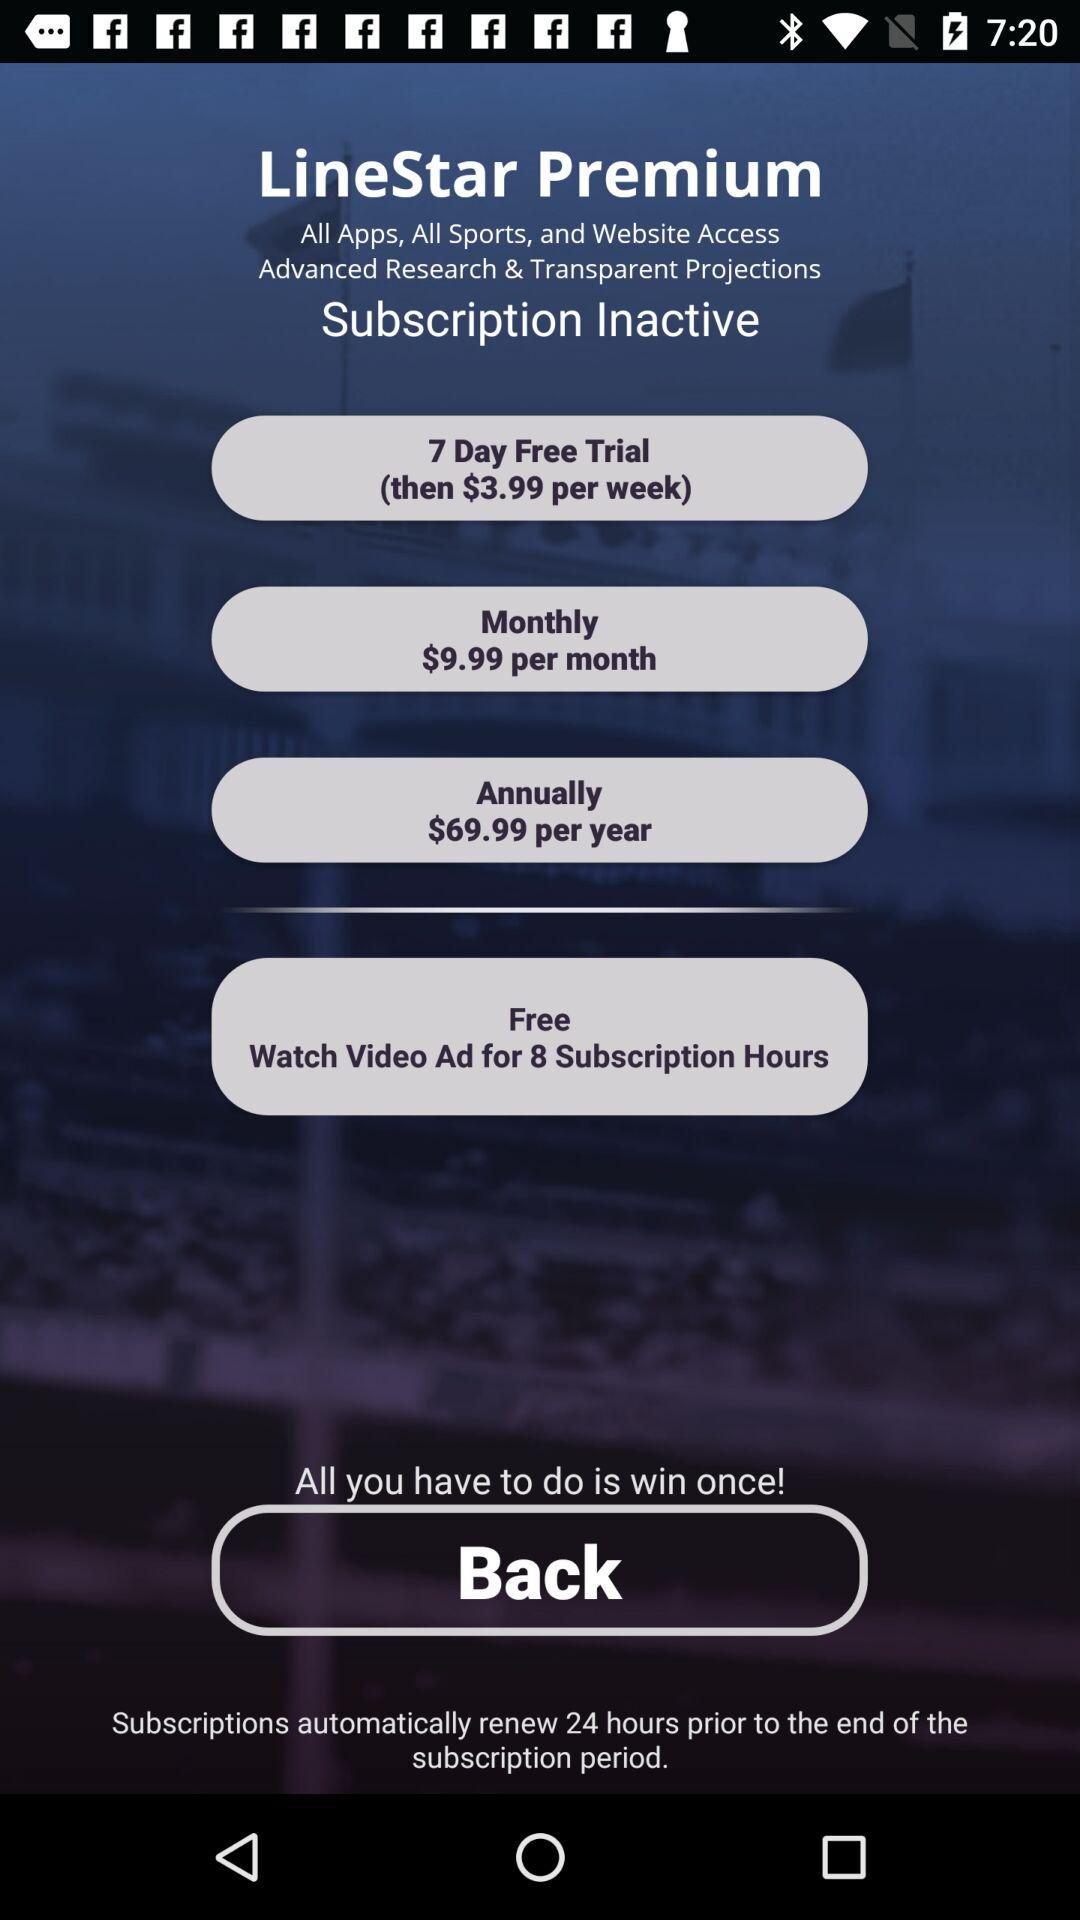For how many days does the free trial last? The free trial period lasts seven days. 